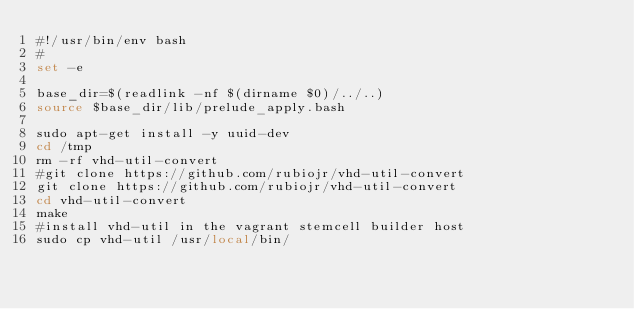Convert code to text. <code><loc_0><loc_0><loc_500><loc_500><_Bash_>#!/usr/bin/env bash
#
set -e

base_dir=$(readlink -nf $(dirname $0)/../..)
source $base_dir/lib/prelude_apply.bash

sudo apt-get install -y uuid-dev
cd /tmp
rm -rf vhd-util-convert 
#git clone https://github.com/rubiojr/vhd-util-convert
git clone https://github.com/rubiojr/vhd-util-convert
cd vhd-util-convert
make
#install vhd-util in the vagrant stemcell builder host
sudo cp vhd-util /usr/local/bin/



</code> 